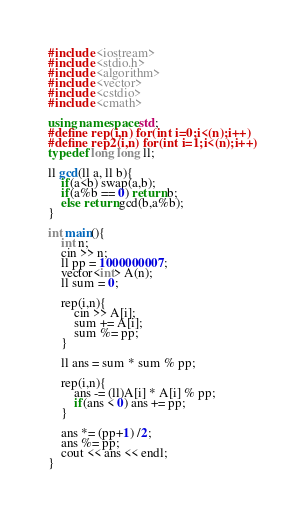Convert code to text. <code><loc_0><loc_0><loc_500><loc_500><_C++_>#include <iostream>
#include <stdio.h>
#include <algorithm>
#include <vector>
#include <cstdio>
#include <cmath>

using namespace std;
#define rep(i,n) for(int i=0;i<(n);i++)
#define rep2(i,n) for(int i=1;i<(n);i++)
typedef long long ll;

ll gcd(ll a, ll b){
    if(a<b) swap(a,b);
    if(a%b == 0) return b;
    else return gcd(b,a%b);
}

int main(){
    int n;
    cin >> n;
    ll pp = 1000000007;
    vector<int> A(n);
    ll sum = 0;

    rep(i,n){
        cin >> A[i];
        sum += A[i];
        sum %= pp;
    }

    ll ans = sum * sum % pp;

    rep(i,n){
        ans -= (ll)A[i] * A[i] % pp;
        if(ans < 0) ans += pp;
    } 

    ans *= (pp+1) /2;
    ans %= pp;
    cout << ans << endl;
}</code> 